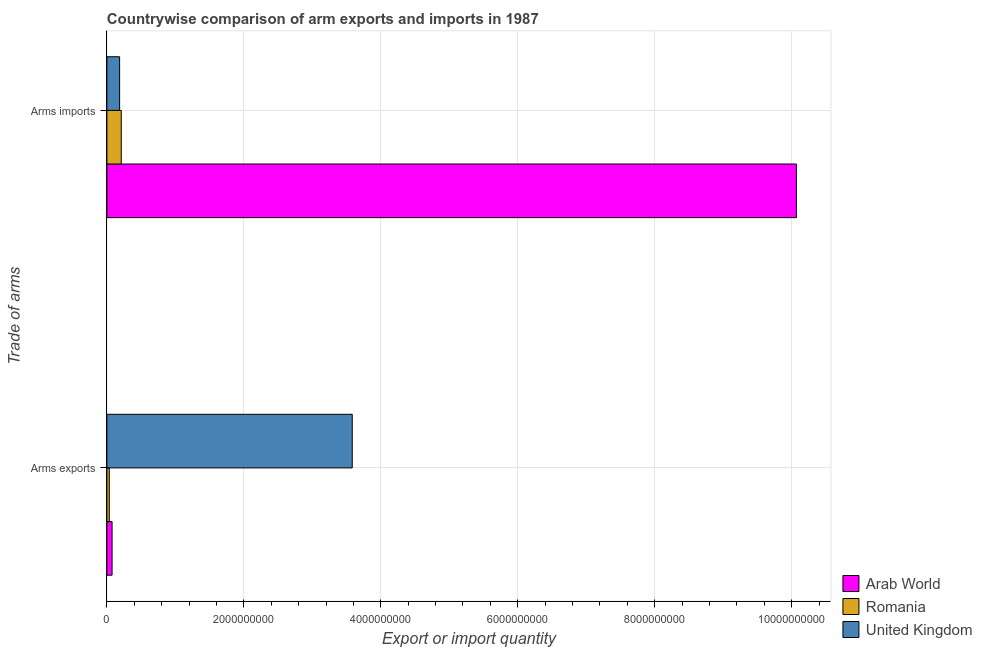How many different coloured bars are there?
Provide a succinct answer. 3. Are the number of bars per tick equal to the number of legend labels?
Give a very brief answer. Yes. What is the label of the 2nd group of bars from the top?
Your answer should be very brief. Arms exports. What is the arms imports in Romania?
Give a very brief answer. 2.10e+08. Across all countries, what is the maximum arms exports?
Keep it short and to the point. 3.58e+09. Across all countries, what is the minimum arms exports?
Give a very brief answer. 3.50e+07. In which country was the arms exports maximum?
Make the answer very short. United Kingdom. What is the total arms imports in the graph?
Keep it short and to the point. 1.05e+1. What is the difference between the arms imports in United Kingdom and that in Romania?
Keep it short and to the point. -2.40e+07. What is the difference between the arms exports in Arab World and the arms imports in Romania?
Your response must be concise. -1.34e+08. What is the average arms exports per country?
Ensure brevity in your answer.  1.23e+09. What is the difference between the arms exports and arms imports in Arab World?
Offer a very short reply. -9.99e+09. In how many countries, is the arms imports greater than 800000000 ?
Your answer should be very brief. 1. What is the ratio of the arms imports in Romania to that in Arab World?
Your answer should be very brief. 0.02. Is the arms exports in United Kingdom less than that in Romania?
Keep it short and to the point. No. In how many countries, is the arms imports greater than the average arms imports taken over all countries?
Provide a succinct answer. 1. What does the 3rd bar from the top in Arms imports represents?
Keep it short and to the point. Arab World. How many bars are there?
Keep it short and to the point. 6. Where does the legend appear in the graph?
Your answer should be compact. Bottom right. How are the legend labels stacked?
Make the answer very short. Vertical. What is the title of the graph?
Give a very brief answer. Countrywise comparison of arm exports and imports in 1987. Does "Uganda" appear as one of the legend labels in the graph?
Ensure brevity in your answer.  No. What is the label or title of the X-axis?
Your response must be concise. Export or import quantity. What is the label or title of the Y-axis?
Your response must be concise. Trade of arms. What is the Export or import quantity in Arab World in Arms exports?
Provide a short and direct response. 7.60e+07. What is the Export or import quantity in Romania in Arms exports?
Ensure brevity in your answer.  3.50e+07. What is the Export or import quantity of United Kingdom in Arms exports?
Give a very brief answer. 3.58e+09. What is the Export or import quantity in Arab World in Arms imports?
Provide a short and direct response. 1.01e+1. What is the Export or import quantity of Romania in Arms imports?
Ensure brevity in your answer.  2.10e+08. What is the Export or import quantity in United Kingdom in Arms imports?
Your response must be concise. 1.86e+08. Across all Trade of arms, what is the maximum Export or import quantity in Arab World?
Offer a very short reply. 1.01e+1. Across all Trade of arms, what is the maximum Export or import quantity in Romania?
Your answer should be very brief. 2.10e+08. Across all Trade of arms, what is the maximum Export or import quantity in United Kingdom?
Give a very brief answer. 3.58e+09. Across all Trade of arms, what is the minimum Export or import quantity in Arab World?
Keep it short and to the point. 7.60e+07. Across all Trade of arms, what is the minimum Export or import quantity of Romania?
Your response must be concise. 3.50e+07. Across all Trade of arms, what is the minimum Export or import quantity of United Kingdom?
Give a very brief answer. 1.86e+08. What is the total Export or import quantity of Arab World in the graph?
Provide a short and direct response. 1.01e+1. What is the total Export or import quantity in Romania in the graph?
Your answer should be compact. 2.45e+08. What is the total Export or import quantity in United Kingdom in the graph?
Your answer should be compact. 3.77e+09. What is the difference between the Export or import quantity of Arab World in Arms exports and that in Arms imports?
Offer a terse response. -9.99e+09. What is the difference between the Export or import quantity in Romania in Arms exports and that in Arms imports?
Your answer should be compact. -1.75e+08. What is the difference between the Export or import quantity of United Kingdom in Arms exports and that in Arms imports?
Make the answer very short. 3.40e+09. What is the difference between the Export or import quantity of Arab World in Arms exports and the Export or import quantity of Romania in Arms imports?
Your answer should be very brief. -1.34e+08. What is the difference between the Export or import quantity of Arab World in Arms exports and the Export or import quantity of United Kingdom in Arms imports?
Keep it short and to the point. -1.10e+08. What is the difference between the Export or import quantity in Romania in Arms exports and the Export or import quantity in United Kingdom in Arms imports?
Provide a succinct answer. -1.51e+08. What is the average Export or import quantity of Arab World per Trade of arms?
Provide a succinct answer. 5.07e+09. What is the average Export or import quantity of Romania per Trade of arms?
Provide a short and direct response. 1.22e+08. What is the average Export or import quantity of United Kingdom per Trade of arms?
Your response must be concise. 1.88e+09. What is the difference between the Export or import quantity in Arab World and Export or import quantity in Romania in Arms exports?
Provide a succinct answer. 4.10e+07. What is the difference between the Export or import quantity in Arab World and Export or import quantity in United Kingdom in Arms exports?
Make the answer very short. -3.51e+09. What is the difference between the Export or import quantity of Romania and Export or import quantity of United Kingdom in Arms exports?
Make the answer very short. -3.55e+09. What is the difference between the Export or import quantity in Arab World and Export or import quantity in Romania in Arms imports?
Provide a short and direct response. 9.86e+09. What is the difference between the Export or import quantity in Arab World and Export or import quantity in United Kingdom in Arms imports?
Ensure brevity in your answer.  9.88e+09. What is the difference between the Export or import quantity of Romania and Export or import quantity of United Kingdom in Arms imports?
Provide a succinct answer. 2.40e+07. What is the ratio of the Export or import quantity in Arab World in Arms exports to that in Arms imports?
Your answer should be compact. 0.01. What is the ratio of the Export or import quantity in United Kingdom in Arms exports to that in Arms imports?
Ensure brevity in your answer.  19.26. What is the difference between the highest and the second highest Export or import quantity in Arab World?
Your answer should be very brief. 9.99e+09. What is the difference between the highest and the second highest Export or import quantity of Romania?
Offer a terse response. 1.75e+08. What is the difference between the highest and the second highest Export or import quantity of United Kingdom?
Your response must be concise. 3.40e+09. What is the difference between the highest and the lowest Export or import quantity of Arab World?
Your answer should be very brief. 9.99e+09. What is the difference between the highest and the lowest Export or import quantity in Romania?
Give a very brief answer. 1.75e+08. What is the difference between the highest and the lowest Export or import quantity of United Kingdom?
Make the answer very short. 3.40e+09. 